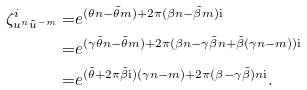Convert formula to latex. <formula><loc_0><loc_0><loc_500><loc_500>\zeta _ { u ^ { n } \tilde { u } ^ { - m } } ^ { i } = & e ^ { ( \theta n - \tilde { \theta } m ) + 2 \pi ( \beta n - \tilde { \beta } m ) \mathrm i } \\ = & e ^ { ( \gamma \tilde { \theta } n - \tilde { \theta } m ) + 2 \pi ( \beta n - \gamma \tilde { \beta } n + \tilde { \beta } ( \gamma n - m ) ) \mathrm i } \\ = & e ^ { ( \tilde { \theta } + 2 \pi \tilde { \beta } \mathrm i ) ( \gamma n - m ) + 2 \pi ( \beta - \gamma \tilde { \beta } ) n \mathrm i } .</formula> 